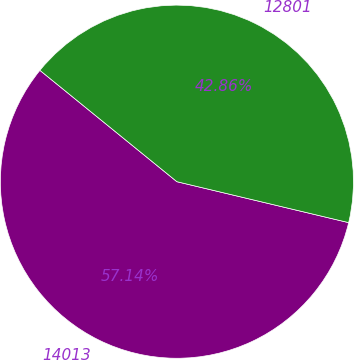<chart> <loc_0><loc_0><loc_500><loc_500><pie_chart><fcel>14013<fcel>12801<nl><fcel>57.14%<fcel>42.86%<nl></chart> 